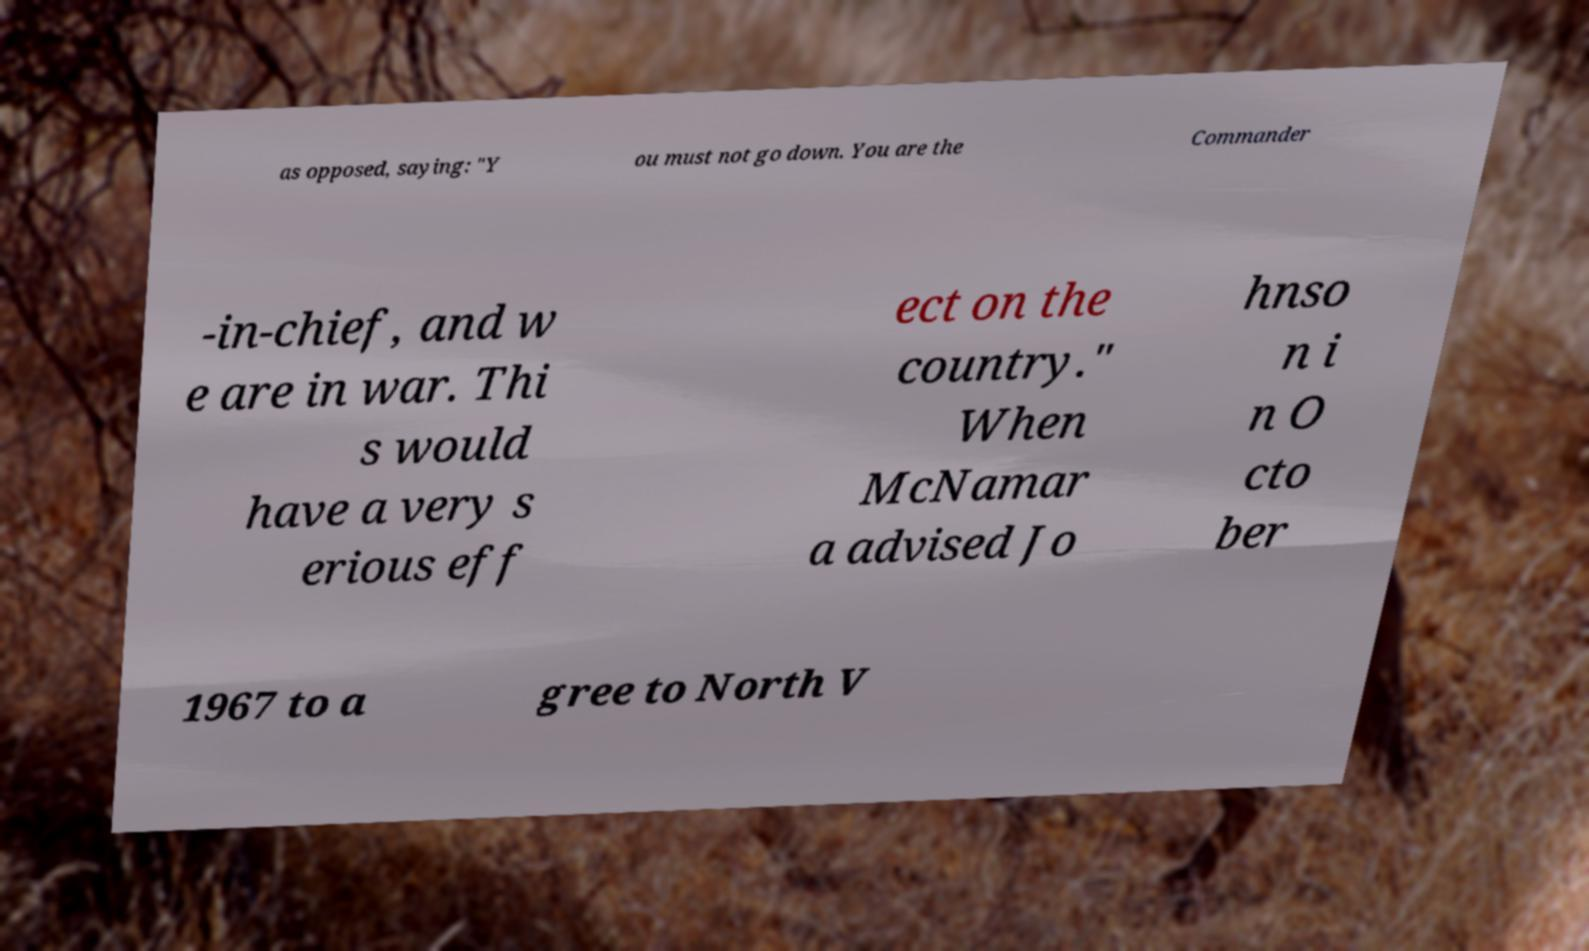I need the written content from this picture converted into text. Can you do that? as opposed, saying: "Y ou must not go down. You are the Commander -in-chief, and w e are in war. Thi s would have a very s erious eff ect on the country." When McNamar a advised Jo hnso n i n O cto ber 1967 to a gree to North V 